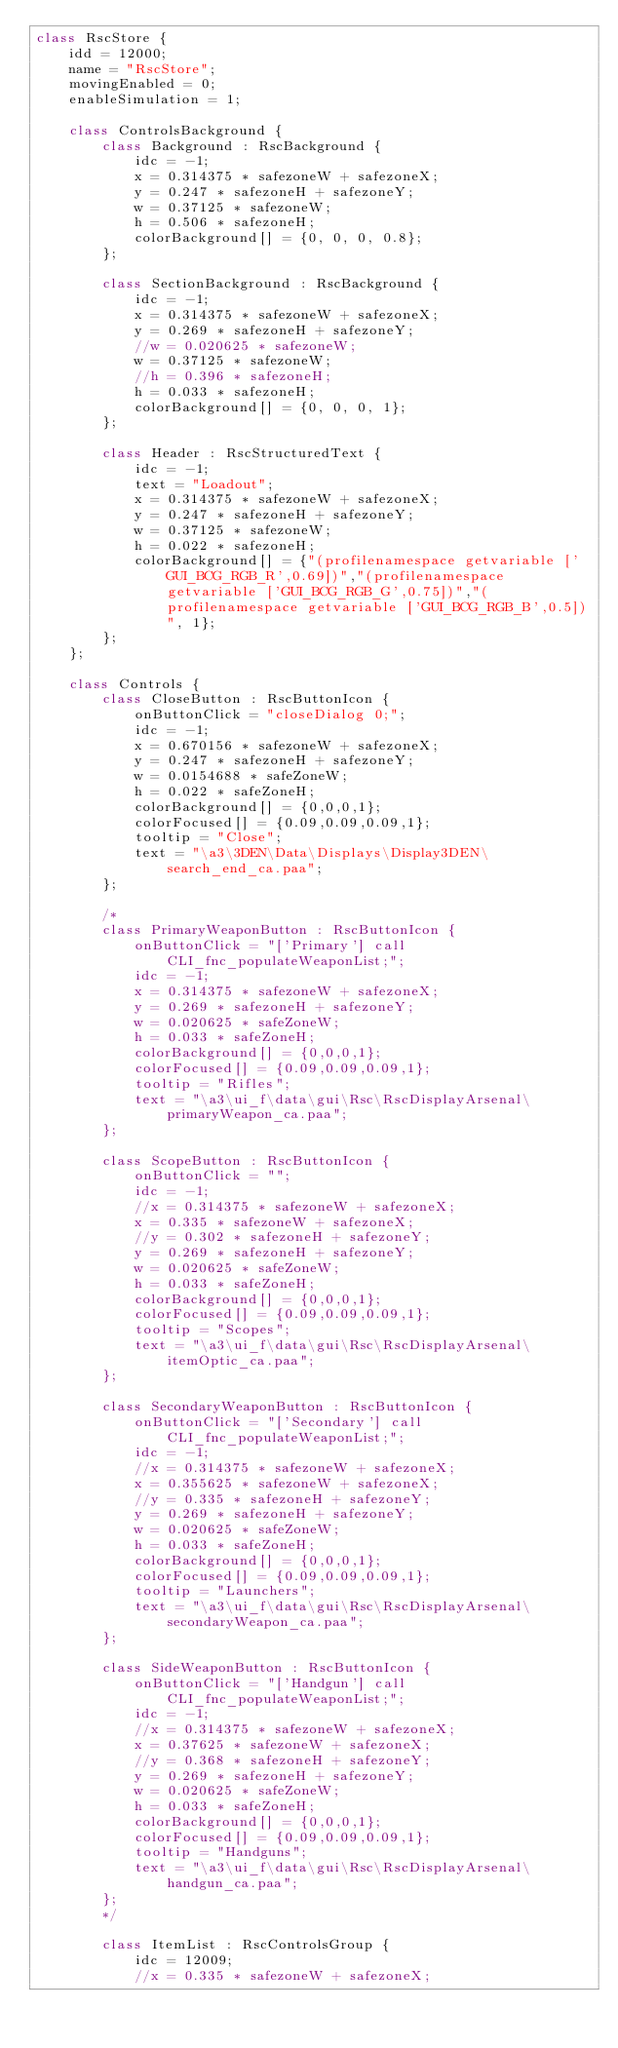<code> <loc_0><loc_0><loc_500><loc_500><_C++_>class RscStore {
	idd = 12000;
	name = "RscStore";
	movingEnabled = 0;
	enableSimulation = 1;

	class ControlsBackground {
		class Background : RscBackground {
			idc = -1;
			x = 0.314375 * safezoneW + safezoneX;
			y = 0.247 * safezoneH + safezoneY;
			w = 0.37125 * safezoneW;
			h = 0.506 * safezoneH;
			colorBackground[] = {0, 0, 0, 0.8};
		};

		class SectionBackground : RscBackground {
			idc = -1;
			x = 0.314375 * safezoneW + safezoneX;
			y = 0.269 * safezoneH + safezoneY;
			//w = 0.020625 * safezoneW;
			w = 0.37125 * safezoneW;
			//h = 0.396 * safezoneH;
			h = 0.033 * safezoneH;
			colorBackground[] = {0, 0, 0, 1};
		};

		class Header : RscStructuredText {
			idc = -1;
			text = "Loadout";
			x = 0.314375 * safezoneW + safezoneX;
			y = 0.247 * safezoneH + safezoneY;
			w = 0.37125 * safezoneW;
			h = 0.022 * safezoneH;
			colorBackground[] = {"(profilenamespace getvariable ['GUI_BCG_RGB_R',0.69])","(profilenamespace getvariable ['GUI_BCG_RGB_G',0.75])","(profilenamespace getvariable ['GUI_BCG_RGB_B',0.5])", 1};
		};
	};

	class Controls {
		class CloseButton : RscButtonIcon {
			onButtonClick = "closeDialog 0;";
			idc = -1;
			x = 0.670156 * safezoneW + safezoneX;
			y = 0.247 * safezoneH + safezoneY;
			w = 0.0154688 * safeZoneW;
			h = 0.022 * safeZoneH;
			colorBackground[] = {0,0,0,1};
			colorFocused[] = {0.09,0.09,0.09,1};
			tooltip = "Close";
			text = "\a3\3DEN\Data\Displays\Display3DEN\search_end_ca.paa";
		};

		/*
		class PrimaryWeaponButton : RscButtonIcon {
			onButtonClick = "['Primary'] call CLI_fnc_populateWeaponList;";
			idc = -1;
			x = 0.314375 * safezoneW + safezoneX;
			y = 0.269 * safezoneH + safezoneY;
			w = 0.020625 * safeZoneW;
			h = 0.033 * safeZoneH;
			colorBackground[] = {0,0,0,1};
			colorFocused[] = {0.09,0.09,0.09,1};
			tooltip = "Rifles";
			text = "\a3\ui_f\data\gui\Rsc\RscDisplayArsenal\primaryWeapon_ca.paa";
		};

		class ScopeButton : RscButtonIcon {
			onButtonClick = "";
			idc = -1;
			//x = 0.314375 * safezoneW + safezoneX;
			x = 0.335 * safezoneW + safezoneX;
			//y = 0.302 * safezoneH + safezoneY;
			y = 0.269 * safezoneH + safezoneY;
			w = 0.020625 * safeZoneW;
			h = 0.033 * safeZoneH;
			colorBackground[] = {0,0,0,1};
			colorFocused[] = {0.09,0.09,0.09,1};
			tooltip = "Scopes";
			text = "\a3\ui_f\data\gui\Rsc\RscDisplayArsenal\itemOptic_ca.paa";
		};

		class SecondaryWeaponButton : RscButtonIcon {
			onButtonClick = "['Secondary'] call CLI_fnc_populateWeaponList;";
			idc = -1;
			//x = 0.314375 * safezoneW + safezoneX;
			x = 0.355625 * safezoneW + safezoneX;
			//y = 0.335 * safezoneH + safezoneY;
			y = 0.269 * safezoneH + safezoneY;
			w = 0.020625 * safeZoneW;
			h = 0.033 * safeZoneH;
			colorBackground[] = {0,0,0,1};
			colorFocused[] = {0.09,0.09,0.09,1};
			tooltip = "Launchers";
			text = "\a3\ui_f\data\gui\Rsc\RscDisplayArsenal\secondaryWeapon_ca.paa";
		};

		class SideWeaponButton : RscButtonIcon {
			onButtonClick = "['Handgun'] call CLI_fnc_populateWeaponList;";
			idc = -1;
			//x = 0.314375 * safezoneW + safezoneX;
			x = 0.37625 * safezoneW + safezoneX;
			//y = 0.368 * safezoneH + safezoneY;
			y = 0.269 * safezoneH + safezoneY;
			w = 0.020625 * safeZoneW;
			h = 0.033 * safeZoneH;
			colorBackground[] = {0,0,0,1};
			colorFocused[] = {0.09,0.09,0.09,1};
			tooltip = "Handguns";
			text = "\a3\ui_f\data\gui\Rsc\RscDisplayArsenal\handgun_ca.paa";
		};
		*/

		class ItemList : RscControlsGroup {
			idc = 12009;
			//x = 0.335 * safezoneW + safezoneX;</code> 